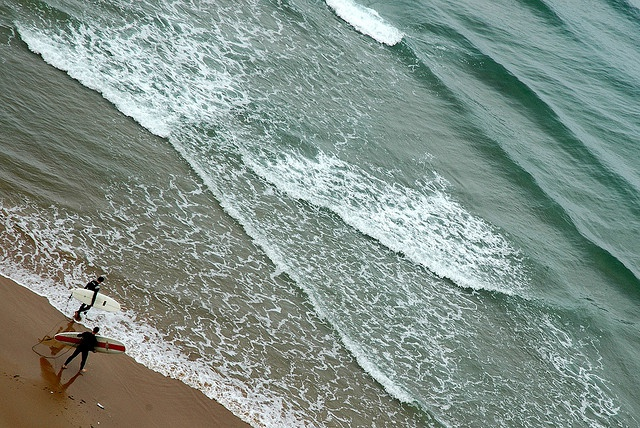Describe the objects in this image and their specific colors. I can see surfboard in gray, maroon, black, and darkgreen tones, surfboard in gray, lightgray, and darkgray tones, people in gray, black, and maroon tones, and people in gray, black, maroon, and darkgray tones in this image. 